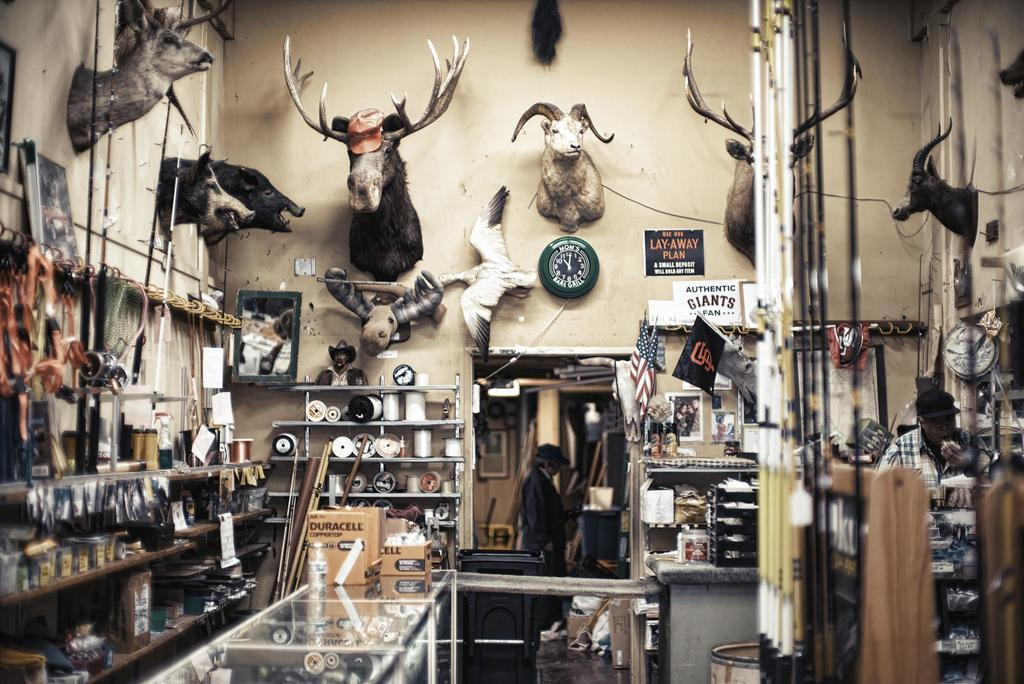Provide a one-sentence caption for the provided image. Sporting goods area that has a clock on the wall that has Mom's Bar & Grill on it. 